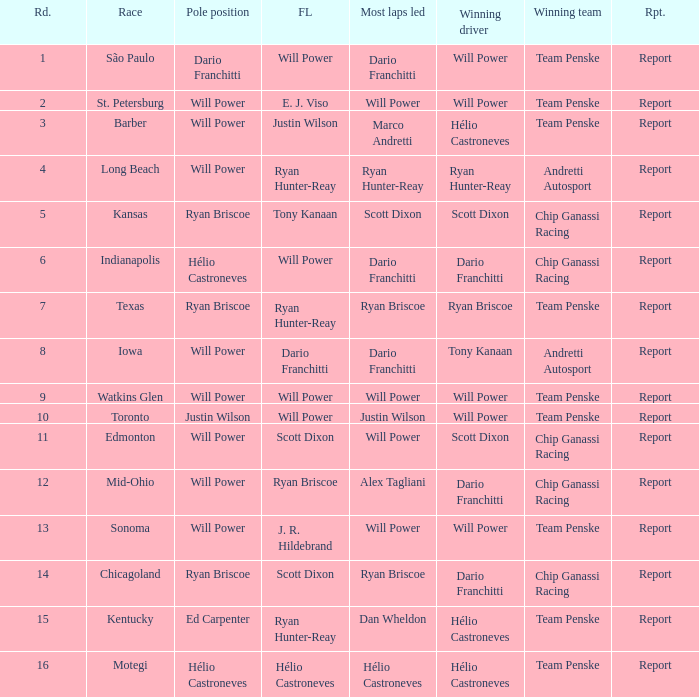Who was on the pole at Chicagoland? Ryan Briscoe. 